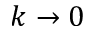Convert formula to latex. <formula><loc_0><loc_0><loc_500><loc_500>k \rightarrow 0</formula> 